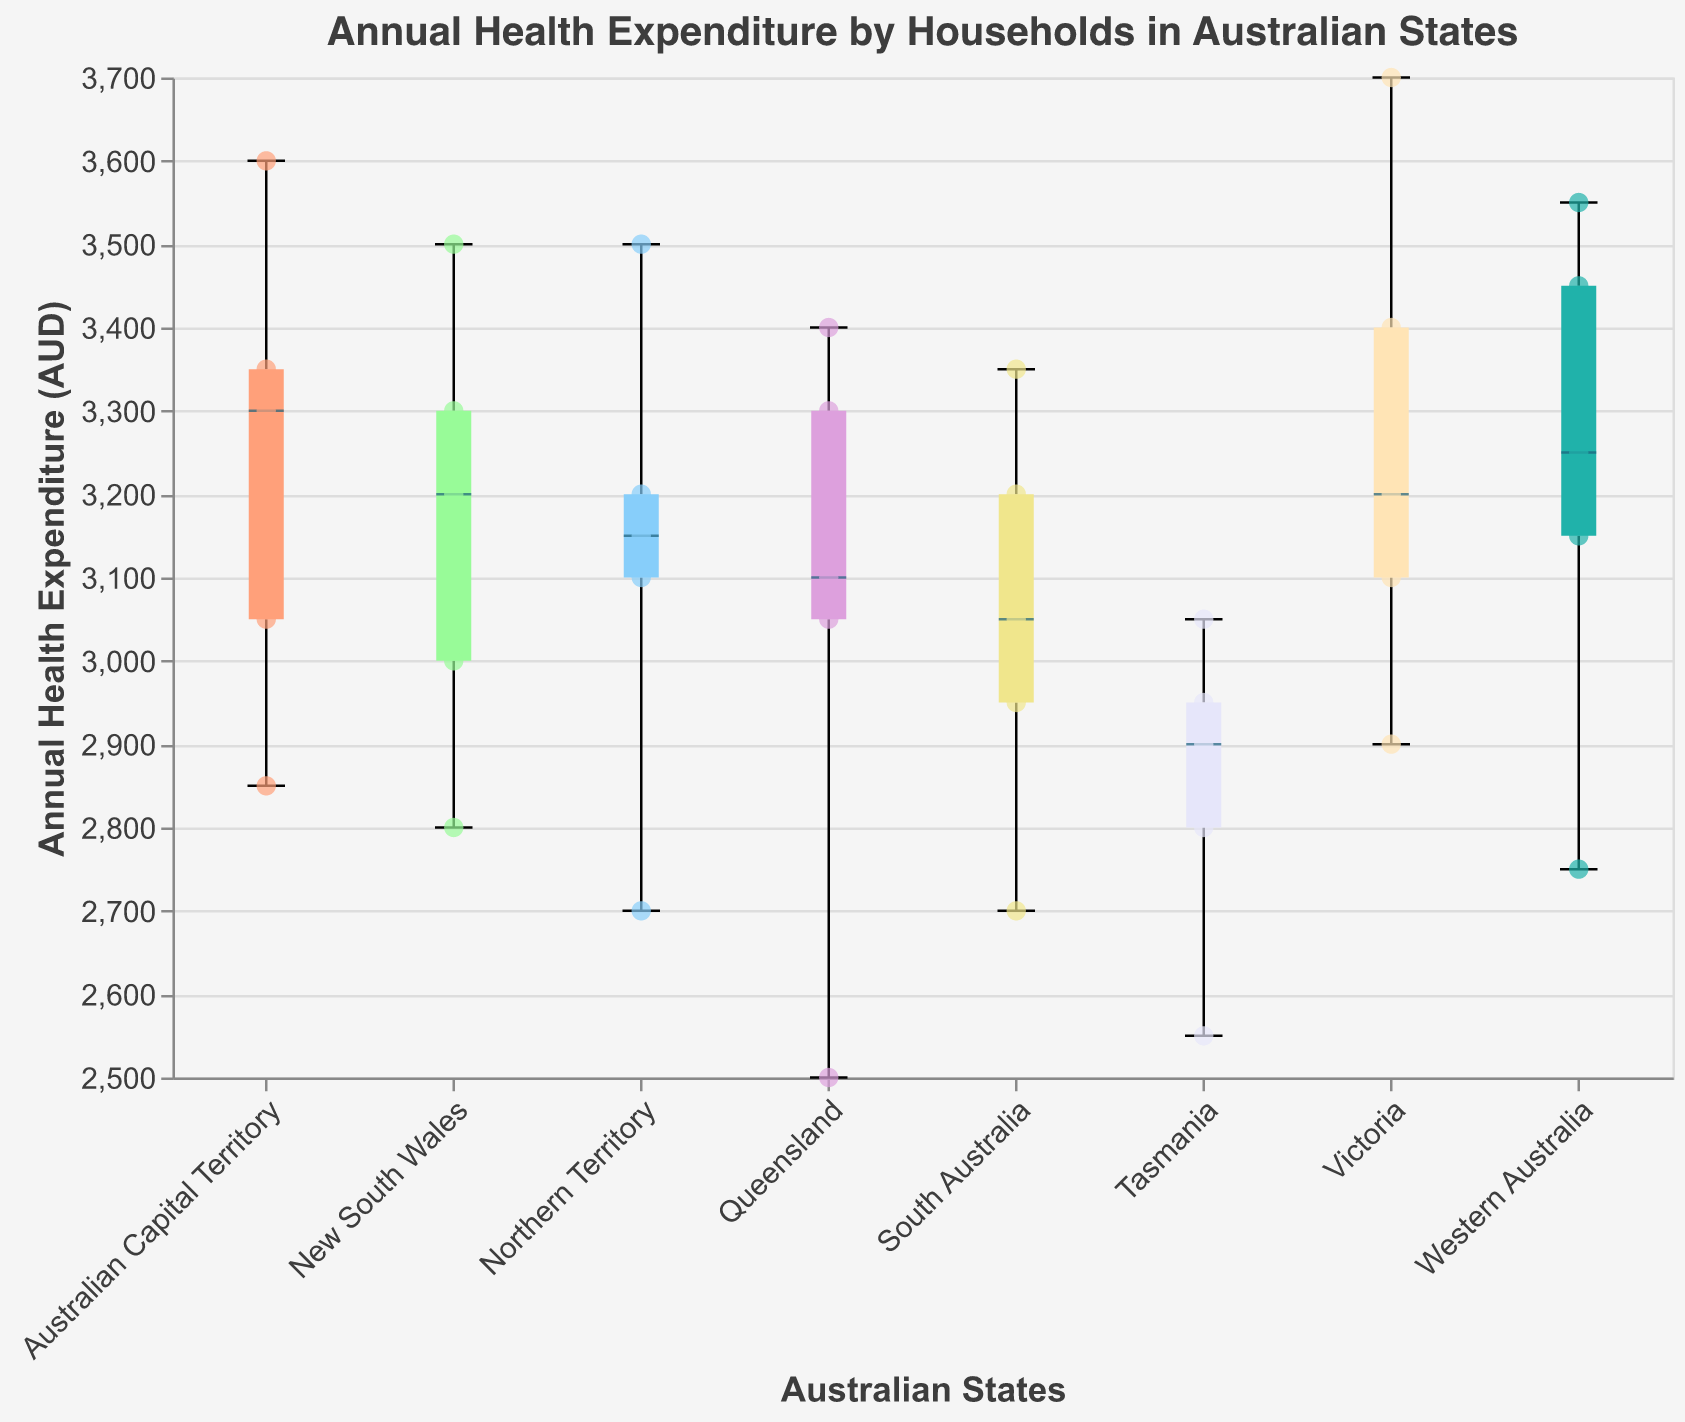What is the title of the figure? The title can be found at the top of the figure. It reads "Annual Health Expenditure by Households in Australian States".
Answer: Annual Health Expenditure by Households in Australian States Which state has the highest median annual health expenditure? The median is often marked by a thicker line within the box of the boxplot. By looking at the visual representation, Western Australia appears to have the highest median, followed closely by the Australian Capital Territory.
Answer: Western Australia What is the range of annual health expenditures in New South Wales? The range in a boxplot is represented from the minimum to the maximum, including outliers. For New South Wales, the minimum is around 2800 AUD and the maximum is around 3500 AUD.
Answer: 2800 to 3500 AUD Which state has the smallest range of annual health expenditures? This can be determined by comparing the lengths of the boxes and whiskers across states. Northern Territory has the smallest range, indicating less variability in annual health expenditures.
Answer: Northern Territory How does the median annual health expenditure in Victoria compare to that in Queensland? The median is represented by a horizontal line inside the box. By observing the figure, Queensland's median is slightly lower than Victoria's.
Answer: Victoria has a higher median than Queensland Are there any outliers in the data for Tasmania? Outliers are typically shown as individual points outside the whiskers of the boxplot. In Tasmania, there are no points outside the whiskers, indicating no outliers.
Answer: No What is the average annual health expenditure for households in New South Wales? Averaging the points for New South Wales: (3000 + 3200 + 2800 + 3500 + 3300) / 5 = 3160 AUD.
Answer: 3160 AUD Which states have annual health expenditures that exceed 3500 AUD? Points above the 3500 AUD line can be seen in Victoria, Northern Territory, and the Australian Capital Territory.
Answer: Victoria, Northern Territory, Australian Capital Territory Do any states have a lower whisker below 2600 AUD? Observing the lower whiskers, Tasmania's lower whisker appears to slightly dip below 2600 AUD.
Answer: Tasmania Which state displays the greatest variability in annual health expenditures? The variability within states can be assessed by the length of the boxes and whiskers. Western Australia shows the largest spread from the minimum to maximum values.
Answer: Western Australia 